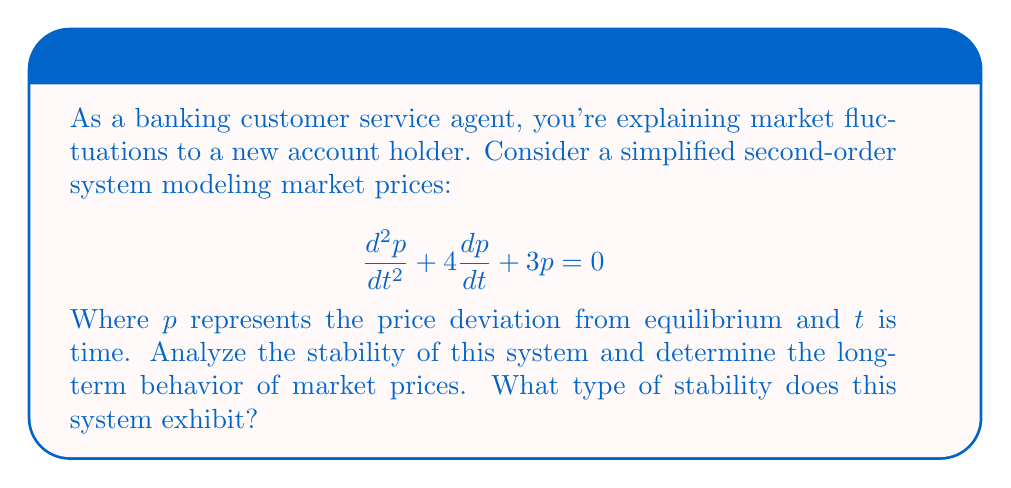Help me with this question. Let's analyze this step-by-step:

1) The characteristic equation for this second-order differential equation is:
   $$r^2 + 4r + 3 = 0$$

2) We can solve this using the quadratic formula: $r = \frac{-b \pm \sqrt{b^2 - 4ac}}{2a}$
   Here, $a=1$, $b=4$, and $c=3$

3) Substituting these values:
   $$r = \frac{-4 \pm \sqrt{16 - 12}}{2} = \frac{-4 \pm \sqrt{4}}{2} = \frac{-4 \pm 2}{2}$$

4) This gives us two roots:
   $$r_1 = \frac{-4 + 2}{2} = -1$$
   $$r_2 = \frac{-4 - 2}{2} = -3$$

5) The general solution to this differential equation is:
   $$p(t) = C_1e^{-t} + C_2e^{-3t}$$
   where $C_1$ and $C_2$ are constants determined by initial conditions.

6) Both exponential terms have negative exponents. This means that as $t$ increases, both terms will approach zero.

7) In the context of stability analysis:
   - Both roots are real and negative.
   - This indicates that the system is overdamped.
   - The solution will decay to zero without oscillation.

8) For market prices, this means that any deviation from the equilibrium price will smoothly return to equilibrium over time, without overshooting or oscillating.

Therefore, this system exhibits asymptotic stability. The market prices will always return to equilibrium, regardless of initial conditions.
Answer: Asymptotically stable 